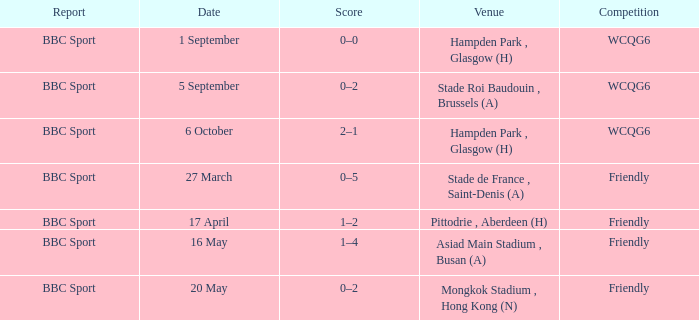Help me parse the entirety of this table. {'header': ['Report', 'Date', 'Score', 'Venue', 'Competition'], 'rows': [['BBC Sport', '1 September', '0–0', 'Hampden Park , Glasgow (H)', 'WCQG6'], ['BBC Sport', '5 September', '0–2', 'Stade Roi Baudouin , Brussels (A)', 'WCQG6'], ['BBC Sport', '6 October', '2–1', 'Hampden Park , Glasgow (H)', 'WCQG6'], ['BBC Sport', '27 March', '0–5', 'Stade de France , Saint-Denis (A)', 'Friendly'], ['BBC Sport', '17 April', '1–2', 'Pittodrie , Aberdeen (H)', 'Friendly'], ['BBC Sport', '16 May', '1–4', 'Asiad Main Stadium , Busan (A)', 'Friendly'], ['BBC Sport', '20 May', '0–2', 'Mongkok Stadium , Hong Kong (N)', 'Friendly']]} Who reported the game on 6 october? BBC Sport. 